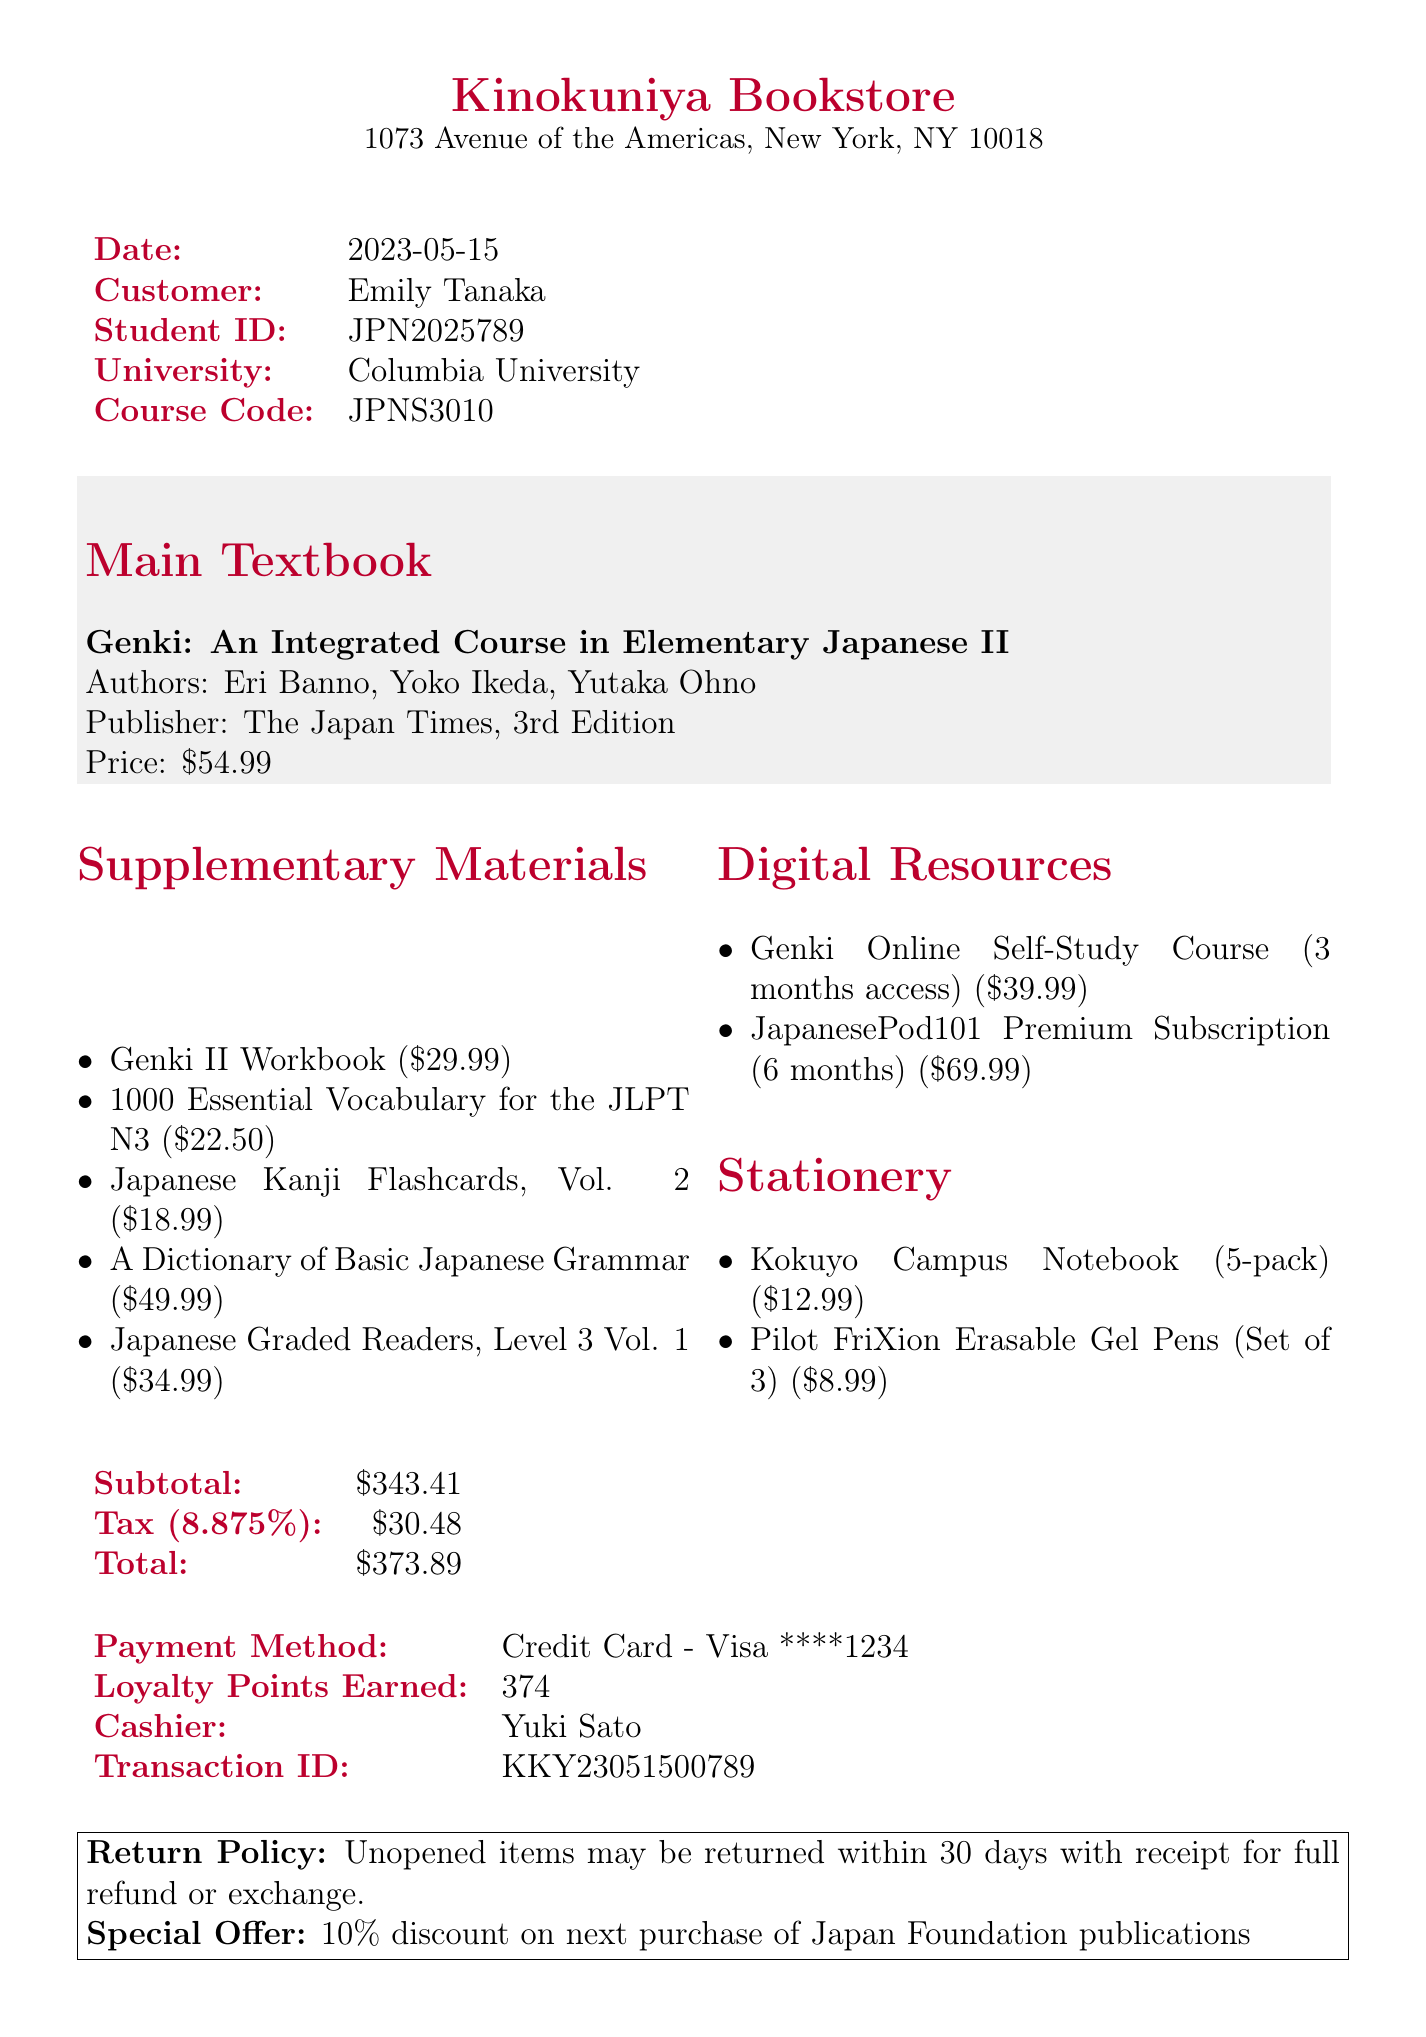what is the store name? The store name is clearly indicated at the top of the document as the point of sale.
Answer: Kinokuniya Bookstore who is the customer? The customer's name is listed in the information at the top of the receipt.
Answer: Emily Tanaka what is the date of the transaction? The date is provided in the document just below the store name, indicating when the purchase was made.
Answer: 2023-05-15 what is the price of the main textbook? The price for the main textbook can be found in the section detailing the main textbook purchase.
Answer: $54.99 how many loyalty points were earned? The total loyalty points earned are explicitly mentioned near the payment details at the bottom.
Answer: 374 what is the subtotal amount? This amount is provided as the sum of all items purchased before tax is added.
Answer: $343.41 which digital resource costs the most? The highest-priced digital resource can be inferred by comparing the prices of all digital resources listed.
Answer: JapanesePod101 Premium Subscription (6 months) what is the return policy? The return policy is noted in the boxed section at the bottom of the document, outlining conditions for returns.
Answer: Unopened items may be returned within 30 days with receipt for full refund or exchange who processed the transaction? The cashier's name is listed in the transaction details, indicating the person who handled the sale.
Answer: Yuki Sato 